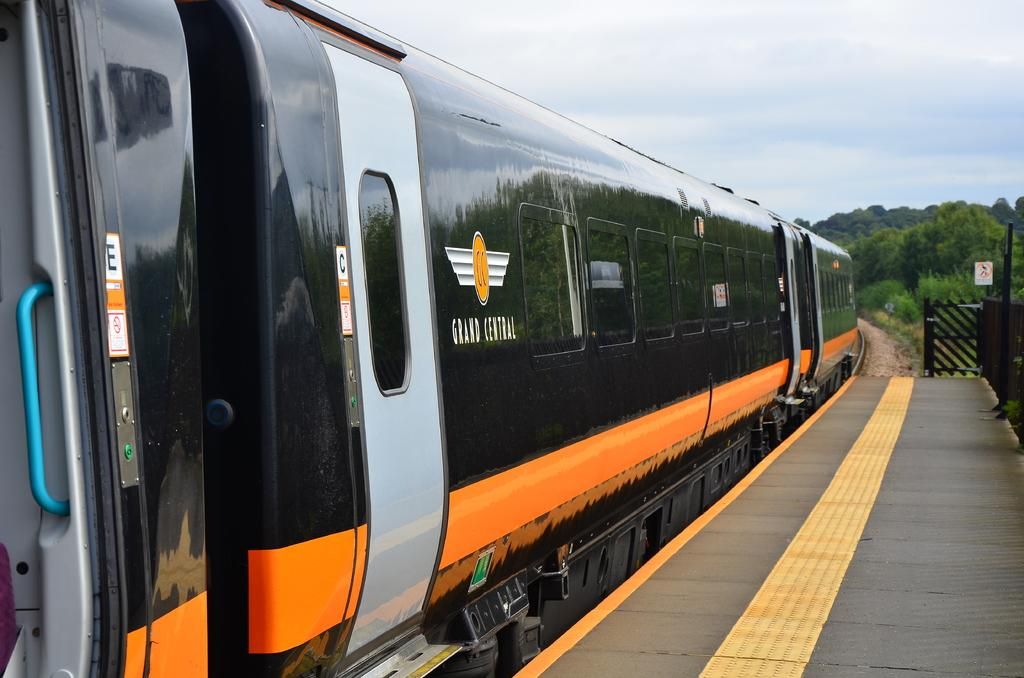What is the main subject of the image? The main subject of the image is a train. Where is the train located in the image? The train is on a railway track. What else can be seen in the image besides the train? There is a railway platform, a fence, trees, and the sky visible in the background. Can you see a chess game being played on the train in the image? There is no chess game visible in the image; it only shows a train on a railway track, a railway platform, a fence, trees, and the sky. 